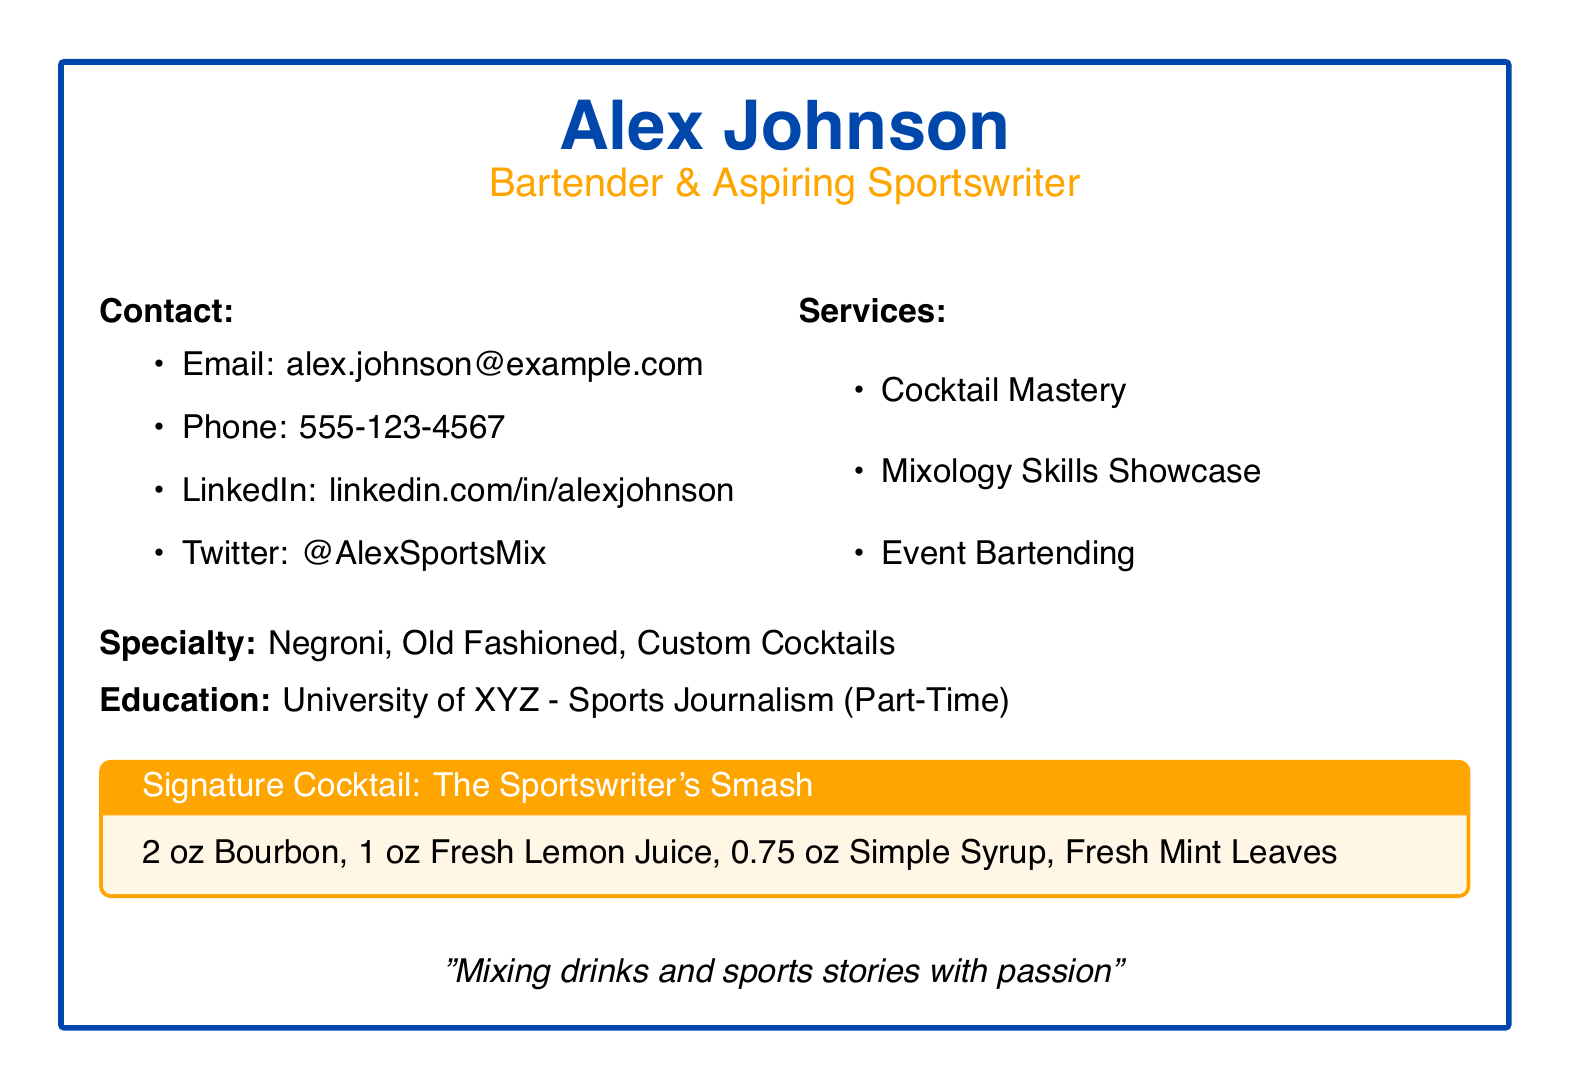What is the name on the business card? The business card displays the name of the individual prominently at the top.
Answer: Alex Johnson What is the primary occupation listed on the card? The primary occupation is specified right below the name.
Answer: Bartender What is the specialty cocktail mentioned? The cocktail highlighted in the document is described towards the bottom within its own box.
Answer: The Sportswriter's Smash What is the contact email provided? The email address is listed under the contact information section of the card.
Answer: alex.johnson@example.com How many services are listed on the card? The number of services can be counted from the services section.
Answer: 3 Which university is mentioned in the education section? The name of the university appears in the education part of the card.
Answer: University of XYZ What is the phone number provided on the card? The phone number is given under the contact section, indicating a way to reach the individual.
Answer: 555-123-4567 Which cocktail ingredient is listed first in the signature cocktail? The order of ingredients is important for the recipe detailed on the card.
Answer: Bourbon What social media platform is mentioned on the card? The card includes a specific platform for professional networking.
Answer: LinkedIn How does Alex Johnson describe his passion on the card? The phrase summarizing Alex's enthusiasm is located at the bottom of the card.
Answer: Mixing drinks and sports stories with passion 